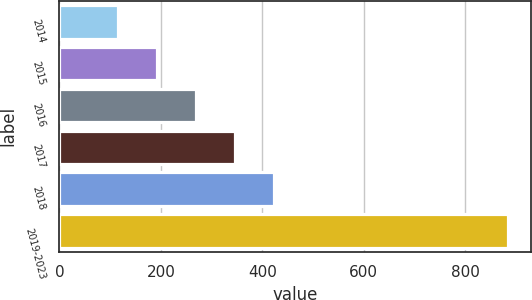Convert chart. <chart><loc_0><loc_0><loc_500><loc_500><bar_chart><fcel>2014<fcel>2015<fcel>2016<fcel>2017<fcel>2018<fcel>2019-2023<nl><fcel>115.6<fcel>192.56<fcel>269.52<fcel>346.48<fcel>423.44<fcel>885.2<nl></chart> 